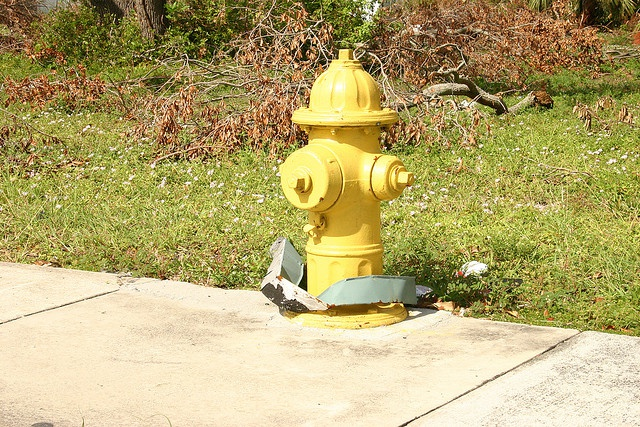Describe the objects in this image and their specific colors. I can see a fire hydrant in maroon, khaki, olive, and orange tones in this image. 